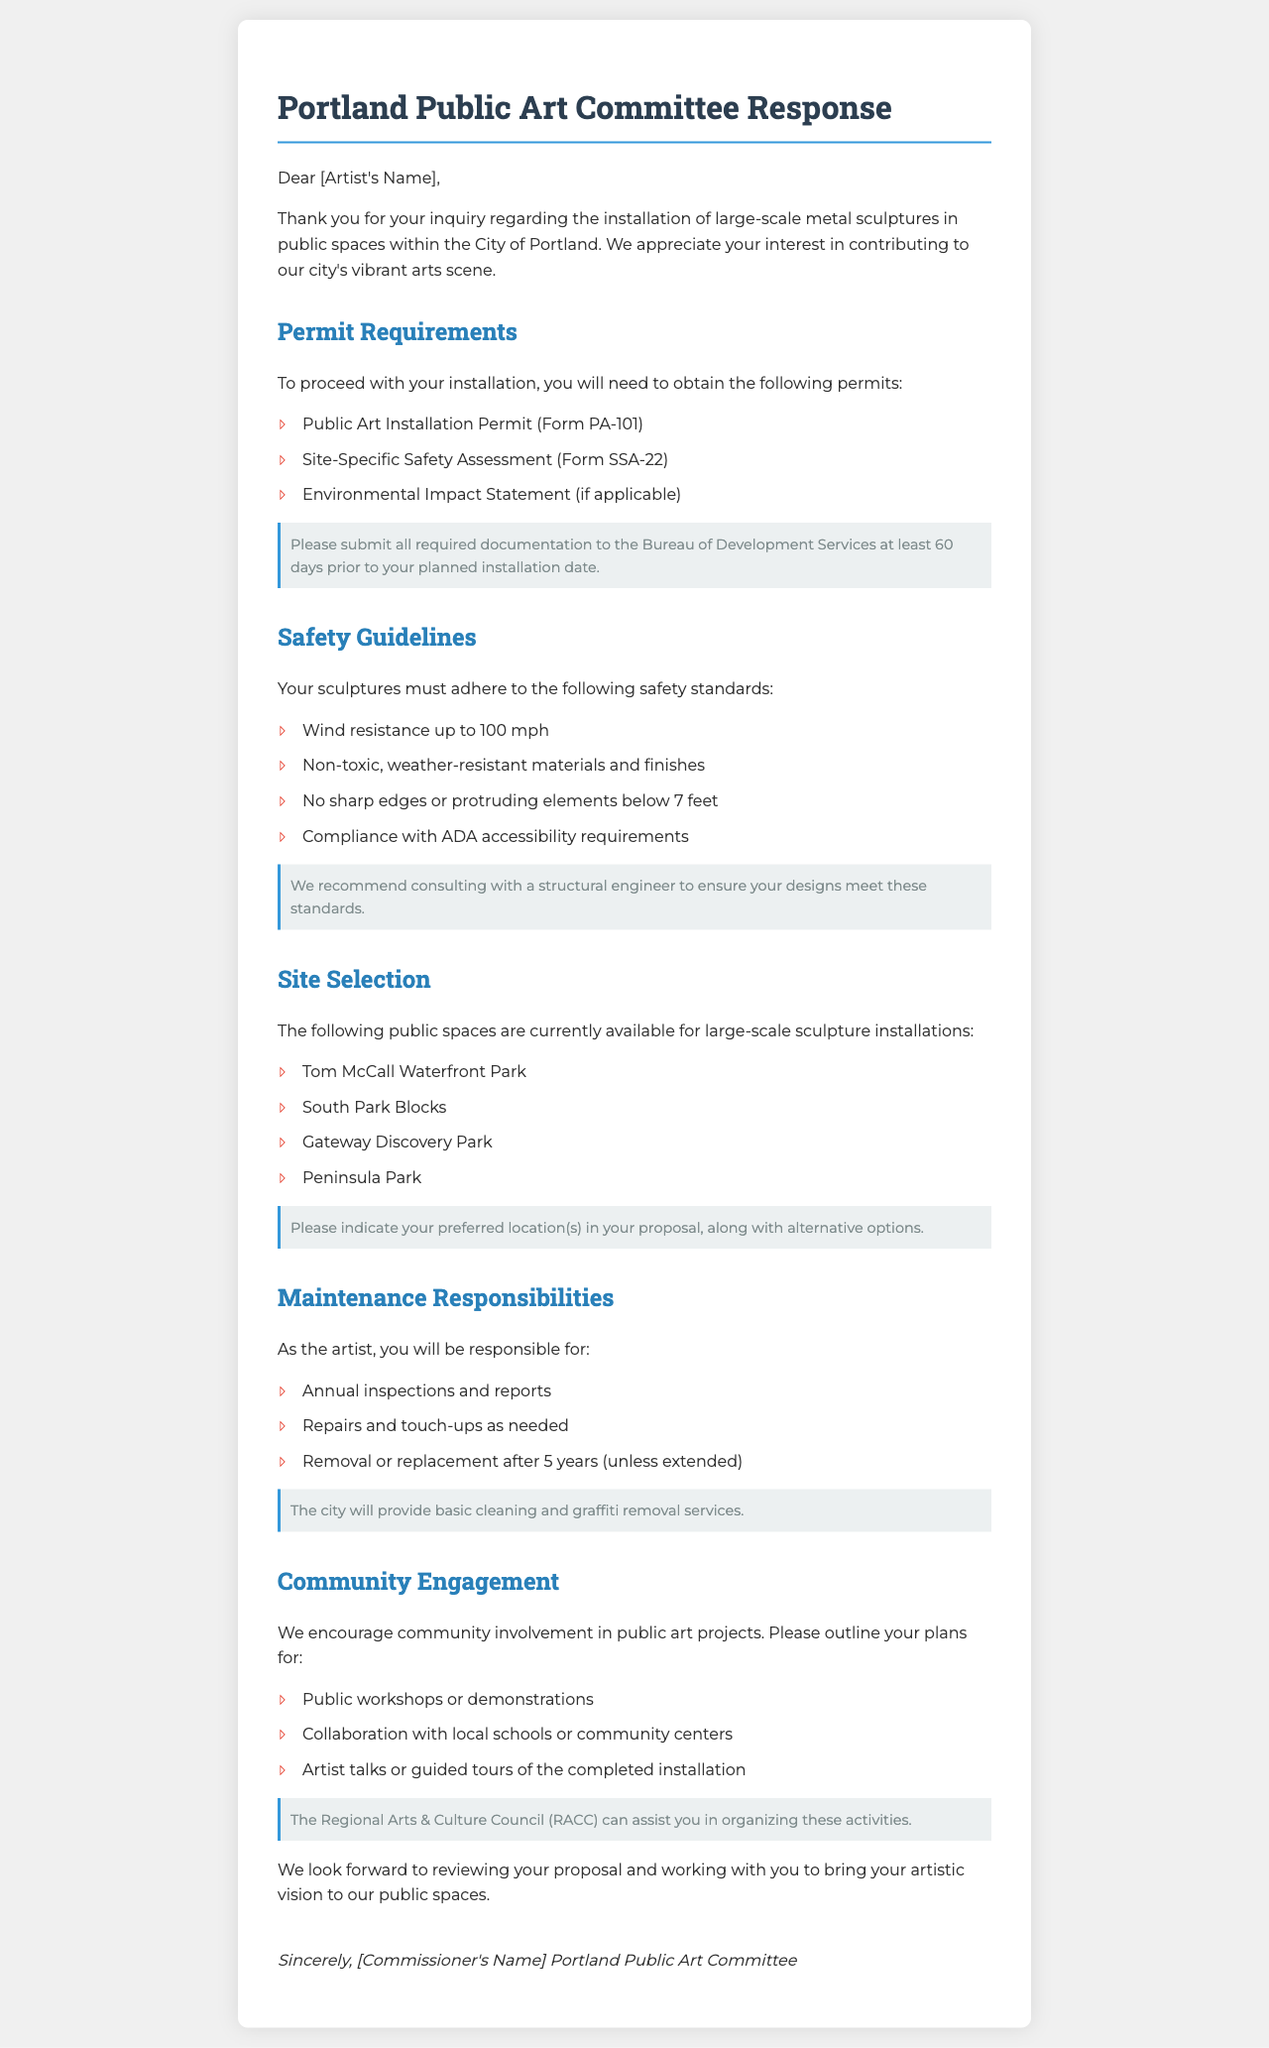What is the first permit required for installation? The first permit listed in the document for installation is the "Public Art Installation Permit (Form PA-101)."
Answer: Public Art Installation Permit (Form PA-101) What is the wind resistance requirement for sculptures? The document specifies that sculptures must have wind resistance up to 100 mph.
Answer: 100 mph Which public space is available for installations? One of the mentioned public spaces available for installation is "Tom McCall Waterfront Park."
Answer: Tom McCall Waterfront Park What annual responsibility does the artist have? According to the document, the artist is responsible for "Annual inspections and reports."
Answer: Annual inspections and reports How long is the maintenance responsibility period? The document states that the artist is responsible for maintenance for "5 years" unless extended.
Answer: 5 years What is a recommended consultation for safety? The document recommends consulting with a "structural engineer" to ensure designs meet safety standards.
Answer: structural engineer What type of community involvement is encouraged? The document encourages community involvement through "Public workshops or demonstrations."
Answer: Public workshops or demonstrations What is the document addressing? The document addresses permits and regulations for installing large-scale metal sculptures in public spaces.
Answer: permits and regulations for installing large-scale metal sculptures 